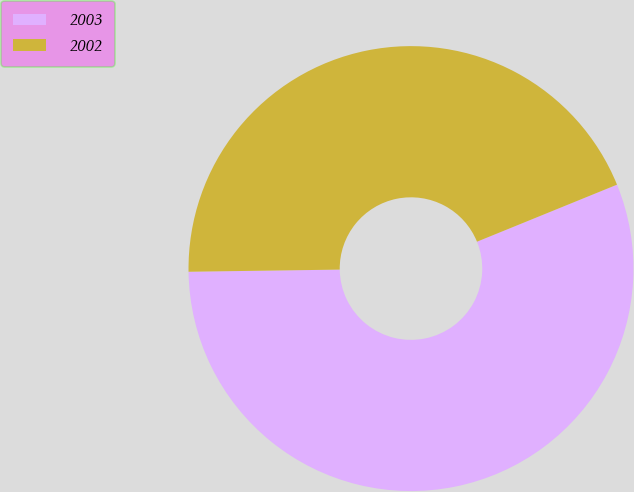Convert chart to OTSL. <chart><loc_0><loc_0><loc_500><loc_500><pie_chart><fcel>2003<fcel>2002<nl><fcel>55.93%<fcel>44.07%<nl></chart> 